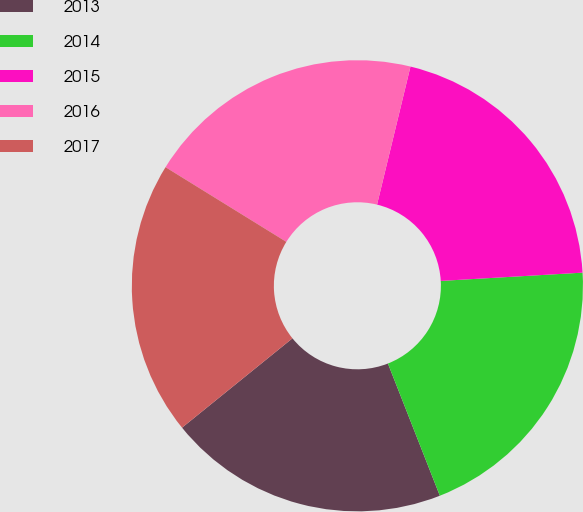Convert chart to OTSL. <chart><loc_0><loc_0><loc_500><loc_500><pie_chart><fcel>2013<fcel>2014<fcel>2015<fcel>2016<fcel>2017<nl><fcel>20.13%<fcel>19.97%<fcel>20.29%<fcel>19.97%<fcel>19.64%<nl></chart> 